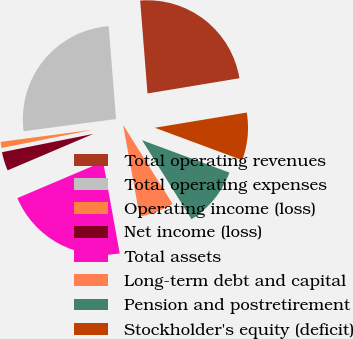Convert chart. <chart><loc_0><loc_0><loc_500><loc_500><pie_chart><fcel>Total operating revenues<fcel>Total operating expenses<fcel>Operating income (loss)<fcel>Net income (loss)<fcel>Total assets<fcel>Long-term debt and capital<fcel>Pension and postretirement<fcel>Stockholder's equity (deficit)<nl><fcel>23.64%<fcel>25.83%<fcel>1.06%<fcel>3.25%<fcel>21.45%<fcel>6.05%<fcel>10.45%<fcel>8.26%<nl></chart> 